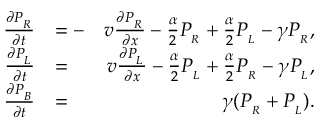Convert formula to latex. <formula><loc_0><loc_0><loc_500><loc_500>\begin{array} { r l r } { \frac { \partial P _ { _ { R } } } { \partial t } } & { = - } & { v \frac { \partial P _ { _ { R } } } { \partial x } - \frac { \alpha } { 2 } P _ { _ { R } } + \frac { \alpha } { 2 } P _ { _ { L } } - \gamma P _ { _ { R } } , } \\ { \frac { \partial P _ { _ { L } } } { \partial t } } & { = } & { v \frac { \partial P _ { _ { L } } } { \partial x } - \frac { \alpha } { 2 } P _ { _ { L } } + \frac { \alpha } { 2 } P _ { _ { R } } - \gamma P _ { _ { L } } , } \\ { \frac { \partial P _ { _ { B } } } { \partial t } } & { = } & { \gamma ( P _ { _ { R } } + P _ { _ { L } } ) . } \end{array}</formula> 